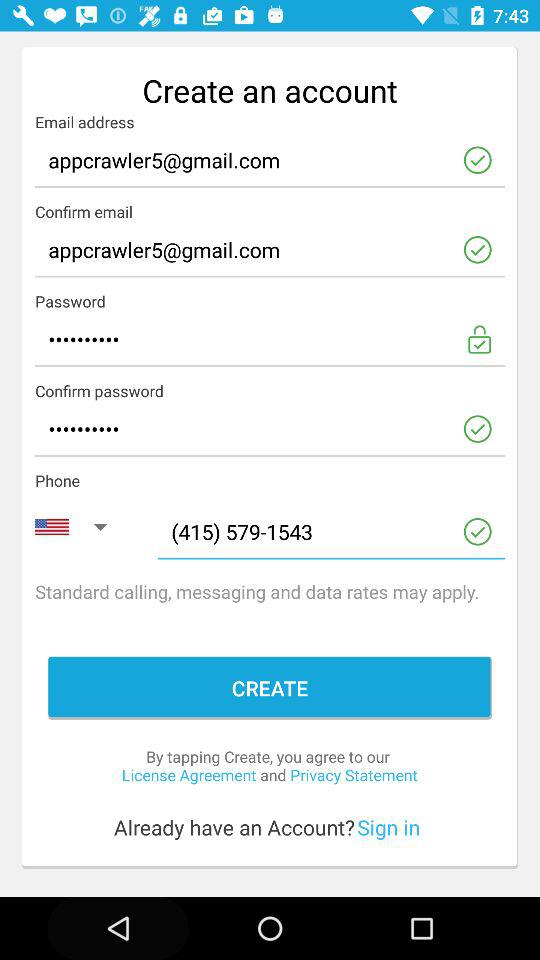What's the email address for the confirmation? The email address is appcrawler5@gmail.com. 